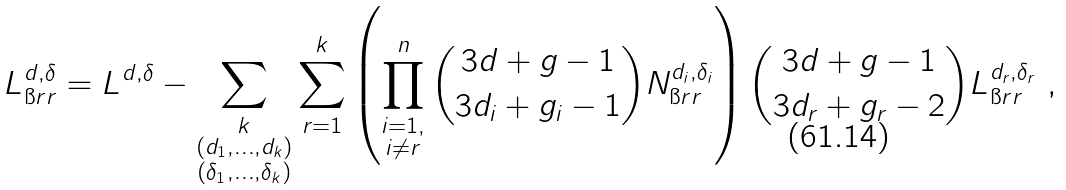<formula> <loc_0><loc_0><loc_500><loc_500>L ^ { d , \delta } _ { \i r r } & = L ^ { d , \delta } - \sum _ { \substack { k \\ ( d _ { 1 } , \dots , d _ { k } ) \\ ( \delta _ { 1 } , \dots , \delta _ { k } ) } } \sum _ { r = 1 } ^ { k } \left ( \prod _ { \substack { i = 1 , \\ i \neq r } } ^ { n } \binom { 3 d + g - 1 } { 3 d _ { i } + g _ { i } - 1 } N _ { \i r r } ^ { d _ { i } , \delta _ { i } } \right ) \binom { 3 d + g - 1 } { 3 d _ { r } + g _ { r } - 2 } L _ { \i r r } ^ { d _ { r } , \delta _ { r } } \ ,</formula> 